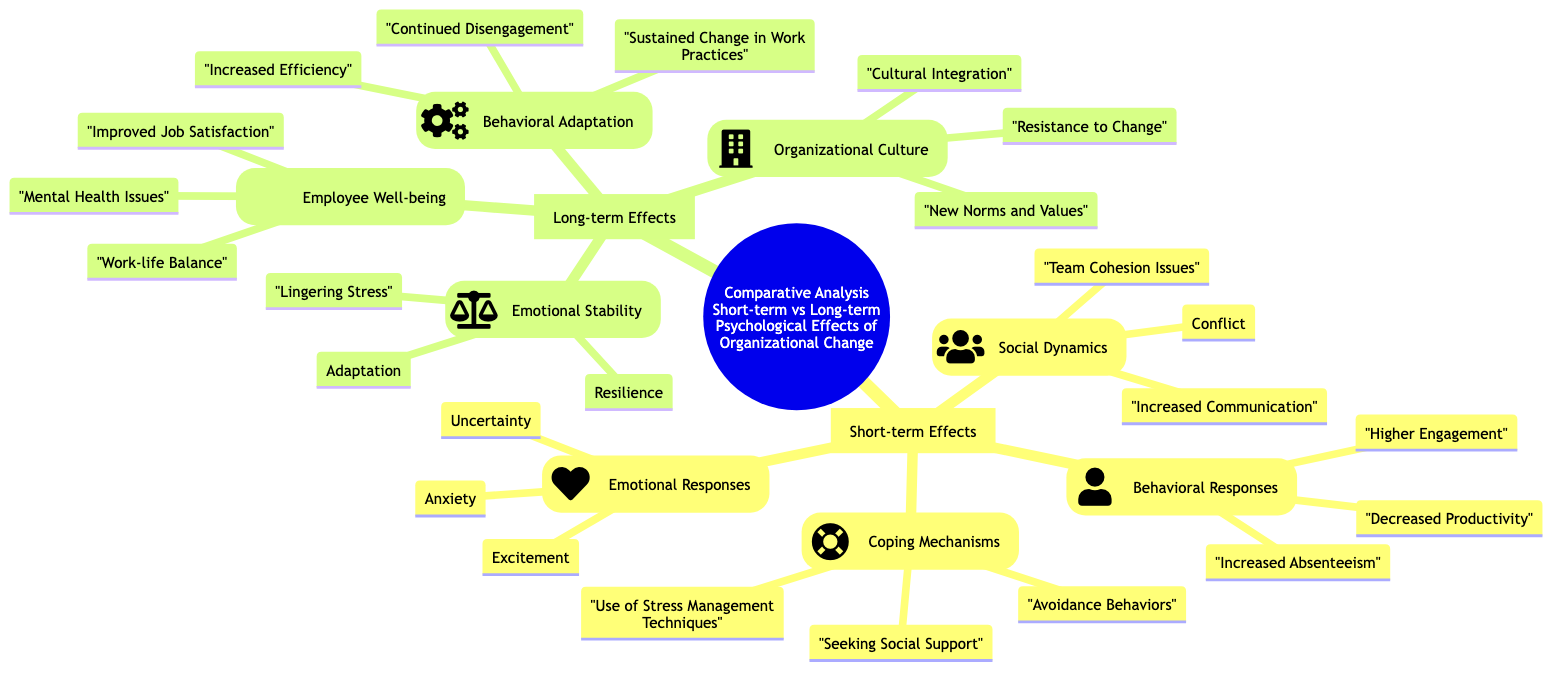What are three emotional responses listed under short-term effects? The diagram indicates three emotional responses in the "Emotional Responses" sub-branch under "Short-term Effects": Anxiety, Uncertainty, and Excitement.
Answer: Anxiety, Uncertainty, Excitement How many main branches are there in the diagram? The diagram has two main branches: "Short-term Effects" and "Long-term Effects", making a total of two.
Answer: 2 What is a coping mechanism mentioned in the short-term effects? Looking at the "Coping Mechanisms" sub-branch under "Short-term Effects", one of the listed responses is "Seeking Social Support".
Answer: Seeking Social Support Which long-term effect relates to organizational culture? Referring to the "Organizational Culture" sub-branch under "Long-term Effects", it indicates that "Cultural Integration" pertains to long-term effects.
Answer: Cultural Integration What is the relationship between short-term absenteeism and long-term employee well-being? The relation suggests that short-term effects like "Increased Absenteeism" may lead to concerns such as "Mental Health Issues" seen under "Employee Well-being" in long-term effects, indicating a potential connection from short to long term.
Answer: Mental Health Issues What is the total number of children listed under Behavioral Responses in short-term effects? In the "Behavioral Responses" sub-branch under "Short-term Effects", there are three listed responses: Decreased Productivity, Increased Absenteeism, and Higher Engagement, totaling three children.
Answer: 3 Which long-term effect reflects adaptation over time? The "Emotional Stability" sub-branch under "Long-term Effects" includes "Adaptation", indicating this aspect of long-term effects.
Answer: Adaptation How does the emotional stability concept relate to resilience in long-term effects? The "Emotional Stability" sub-branch mentions both "Adaptation" and "Resilience", thereby indicating that resilience is an aspect of emotional stability in the context of long-term effects following organizational change.
Answer: Resilience 